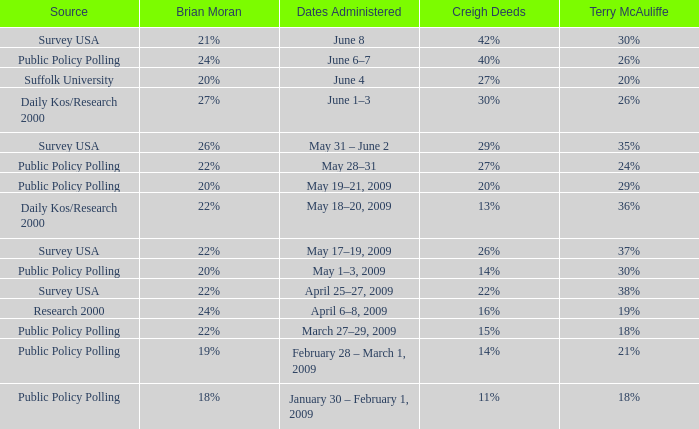What is the percentage of Terry McAuliffe that has a Date Administered on May 31 – june 2 35%. 